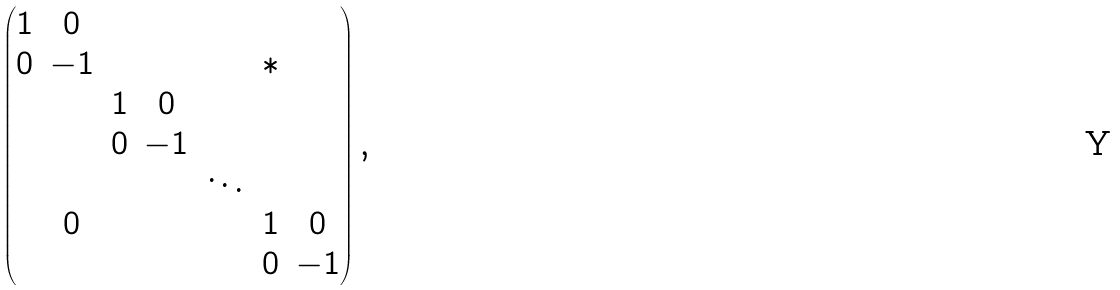<formula> <loc_0><loc_0><loc_500><loc_500>\begin{pmatrix} 1 & 0 & & & & & \\ 0 & - 1 & & & & * & \\ & & 1 & 0 & & & \\ & & 0 & - 1 & & & \\ & & & & \ddots & & \\ & 0 & & & & 1 & 0 \\ & & & & & 0 & - 1 \end{pmatrix} ,</formula> 